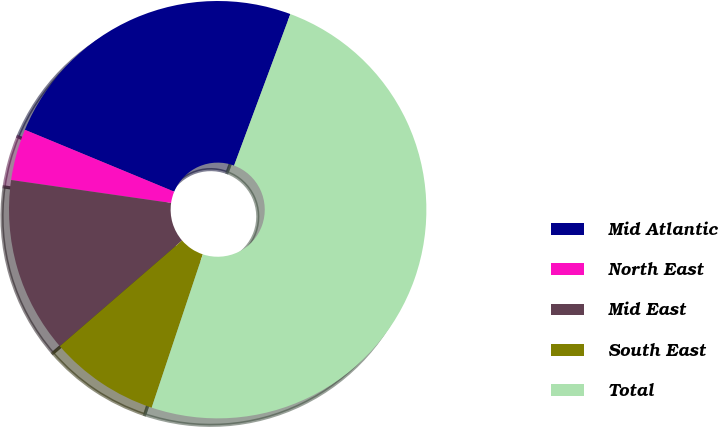Convert chart to OTSL. <chart><loc_0><loc_0><loc_500><loc_500><pie_chart><fcel>Mid Atlantic<fcel>North East<fcel>Mid East<fcel>South East<fcel>Total<nl><fcel>24.41%<fcel>3.98%<fcel>13.62%<fcel>8.53%<fcel>49.46%<nl></chart> 